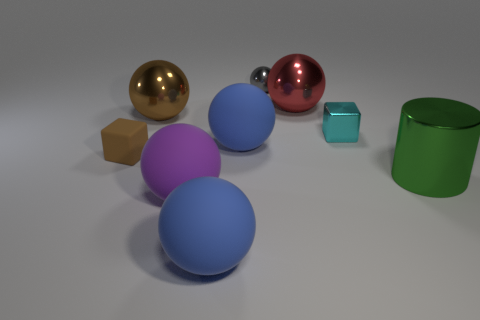Subtract all red spheres. How many spheres are left? 5 Add 1 tiny blue things. How many objects exist? 10 Subtract all gray blocks. How many blue spheres are left? 2 Subtract 1 cylinders. How many cylinders are left? 0 Subtract all gray balls. How many balls are left? 5 Subtract all spheres. How many objects are left? 3 Subtract all yellow balls. Subtract all blue cylinders. How many balls are left? 6 Subtract 0 cyan balls. How many objects are left? 9 Subtract all large purple rubber spheres. Subtract all tiny rubber cubes. How many objects are left? 7 Add 3 brown balls. How many brown balls are left? 4 